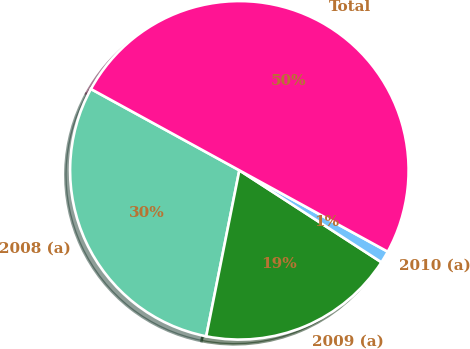<chart> <loc_0><loc_0><loc_500><loc_500><pie_chart><fcel>2008 (a)<fcel>2009 (a)<fcel>2010 (a)<fcel>Total<nl><fcel>29.84%<fcel>18.99%<fcel>1.16%<fcel>50.0%<nl></chart> 